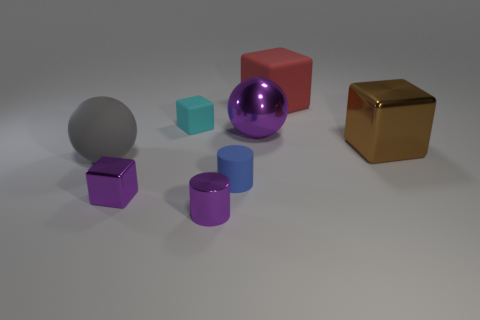Does the brown thing have the same shape as the large object left of the small blue matte cylinder? No, the brown object is a cube with six equal square faces, while the large object to the left of the small blue matte cylinder is a sphere, which is perfectly round and has no edges or faces. 